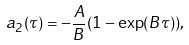Convert formula to latex. <formula><loc_0><loc_0><loc_500><loc_500>a _ { 2 } ( \tau ) = - \frac { A } { B } ( 1 - \exp ( B \tau ) ) ,</formula> 